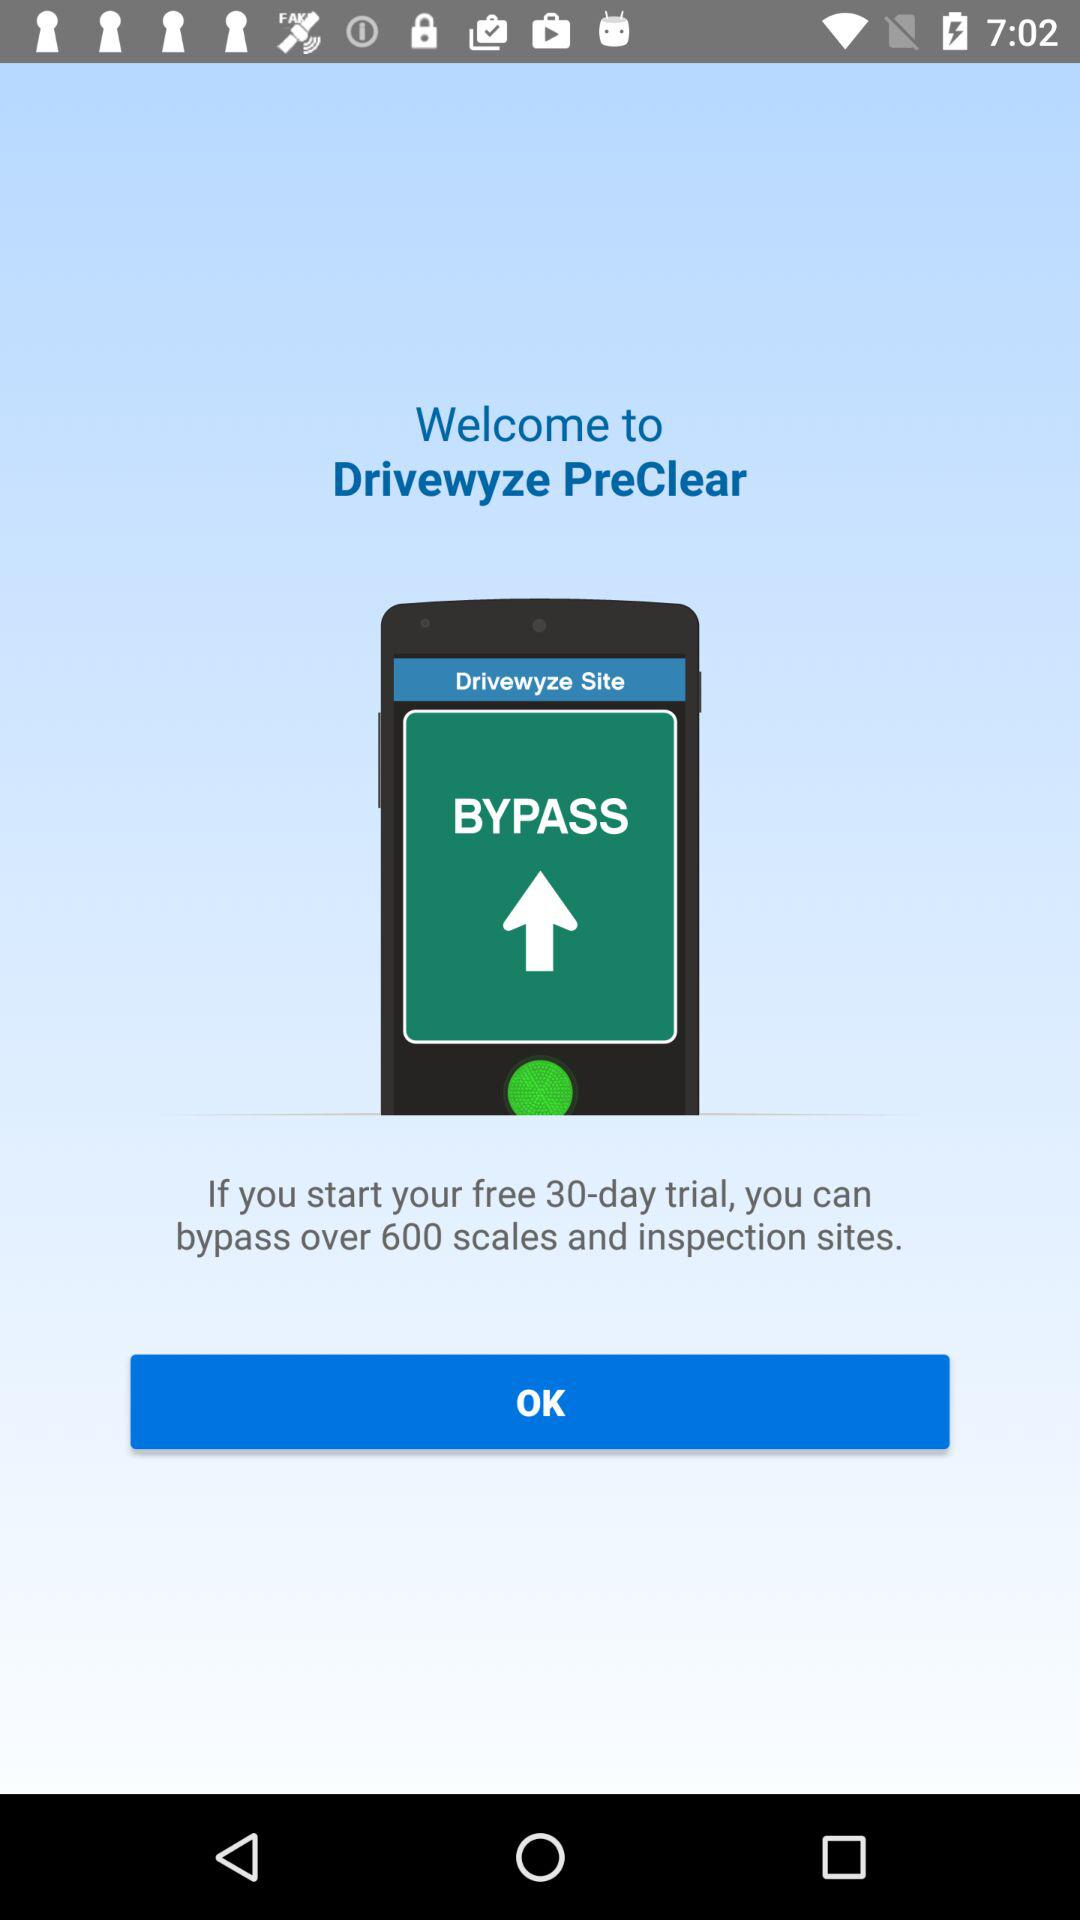How many days of the trial are free? There are 30 free trial days. 